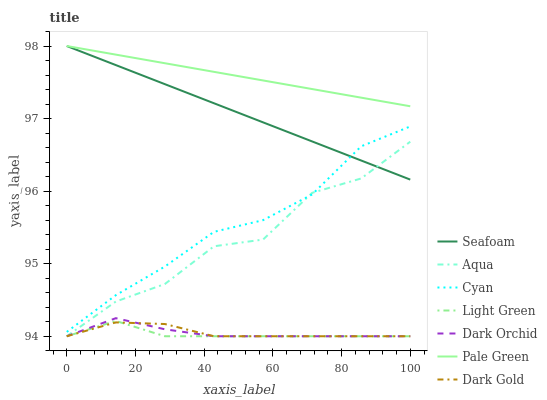Does Light Green have the minimum area under the curve?
Answer yes or no. Yes. Does Pale Green have the maximum area under the curve?
Answer yes or no. Yes. Does Aqua have the minimum area under the curve?
Answer yes or no. No. Does Aqua have the maximum area under the curve?
Answer yes or no. No. Is Seafoam the smoothest?
Answer yes or no. Yes. Is Aqua the roughest?
Answer yes or no. Yes. Is Aqua the smoothest?
Answer yes or no. No. Is Seafoam the roughest?
Answer yes or no. No. Does Dark Gold have the lowest value?
Answer yes or no. Yes. Does Seafoam have the lowest value?
Answer yes or no. No. Does Pale Green have the highest value?
Answer yes or no. Yes. Does Aqua have the highest value?
Answer yes or no. No. Is Light Green less than Pale Green?
Answer yes or no. Yes. Is Cyan greater than Dark Orchid?
Answer yes or no. Yes. Does Dark Orchid intersect Light Green?
Answer yes or no. Yes. Is Dark Orchid less than Light Green?
Answer yes or no. No. Is Dark Orchid greater than Light Green?
Answer yes or no. No. Does Light Green intersect Pale Green?
Answer yes or no. No. 